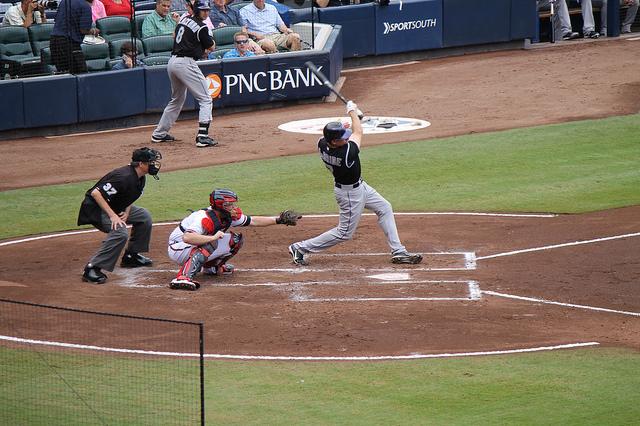What is the title of the man in black?
Give a very brief answer. Umpire. What sport is being played?
Be succinct. Baseball. Is SportSouth a sponsor?
Keep it brief. Yes. Who is wearing number 8?
Concise answer only. On deck batter. 